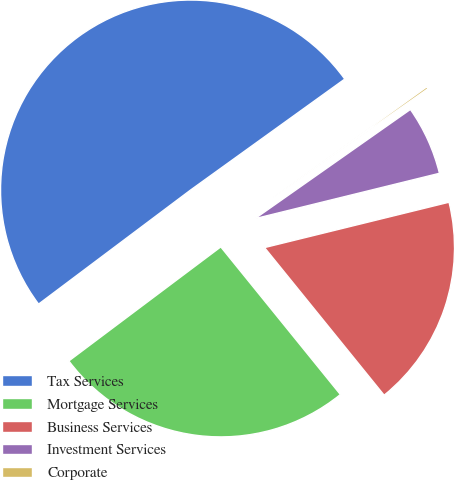Convert chart to OTSL. <chart><loc_0><loc_0><loc_500><loc_500><pie_chart><fcel>Tax Services<fcel>Mortgage Services<fcel>Business Services<fcel>Investment Services<fcel>Corporate<nl><fcel>50.32%<fcel>25.59%<fcel>18.0%<fcel>5.91%<fcel>0.18%<nl></chart> 